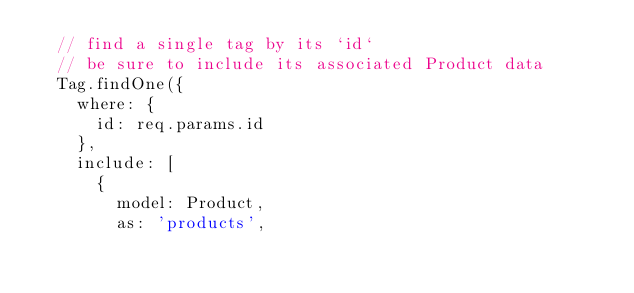<code> <loc_0><loc_0><loc_500><loc_500><_JavaScript_>  // find a single tag by its `id`
  // be sure to include its associated Product data
  Tag.findOne({
    where: {
      id: req.params.id
    },
    include: [
      {
        model: Product,
        as: 'products',</code> 